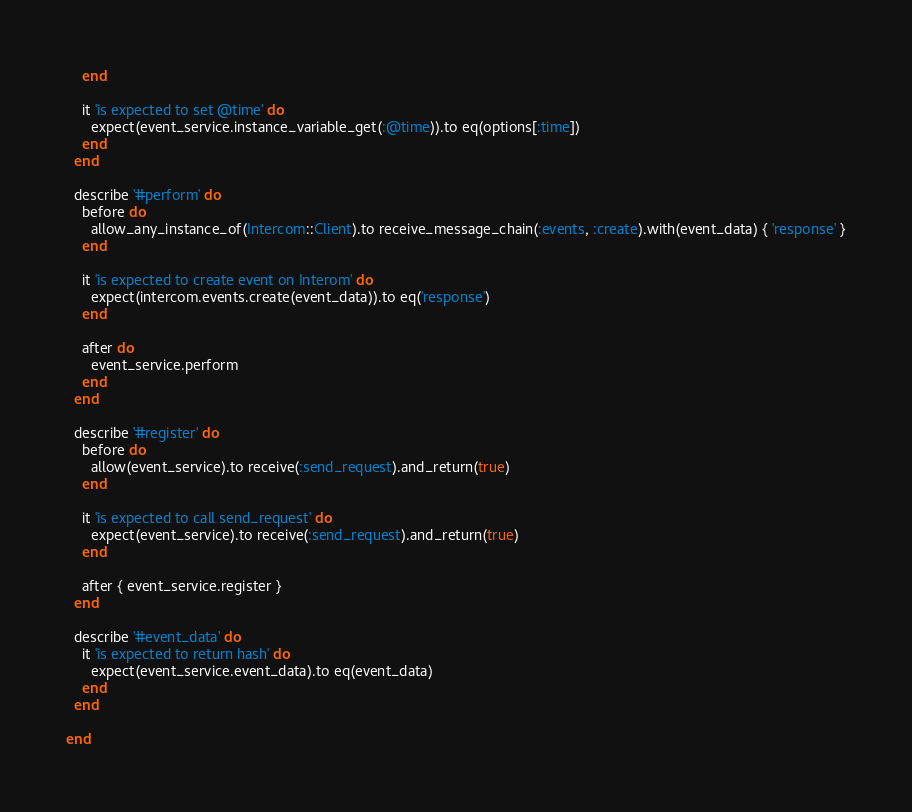Convert code to text. <code><loc_0><loc_0><loc_500><loc_500><_Ruby_>    end

    it 'is expected to set @time' do
      expect(event_service.instance_variable_get(:@time)).to eq(options[:time])
    end
  end

  describe '#perform' do
    before do
      allow_any_instance_of(Intercom::Client).to receive_message_chain(:events, :create).with(event_data) { 'response' }
    end

    it 'is expected to create event on Interom' do
      expect(intercom.events.create(event_data)).to eq('response')
    end

    after do
      event_service.perform
    end
  end

  describe '#register' do
    before do
      allow(event_service).to receive(:send_request).and_return(true)
    end

    it 'is expected to call send_request' do
      expect(event_service).to receive(:send_request).and_return(true)
    end

    after { event_service.register }
  end

  describe '#event_data' do
    it 'is expected to return hash' do
      expect(event_service.event_data).to eq(event_data)
    end
  end

end
</code> 